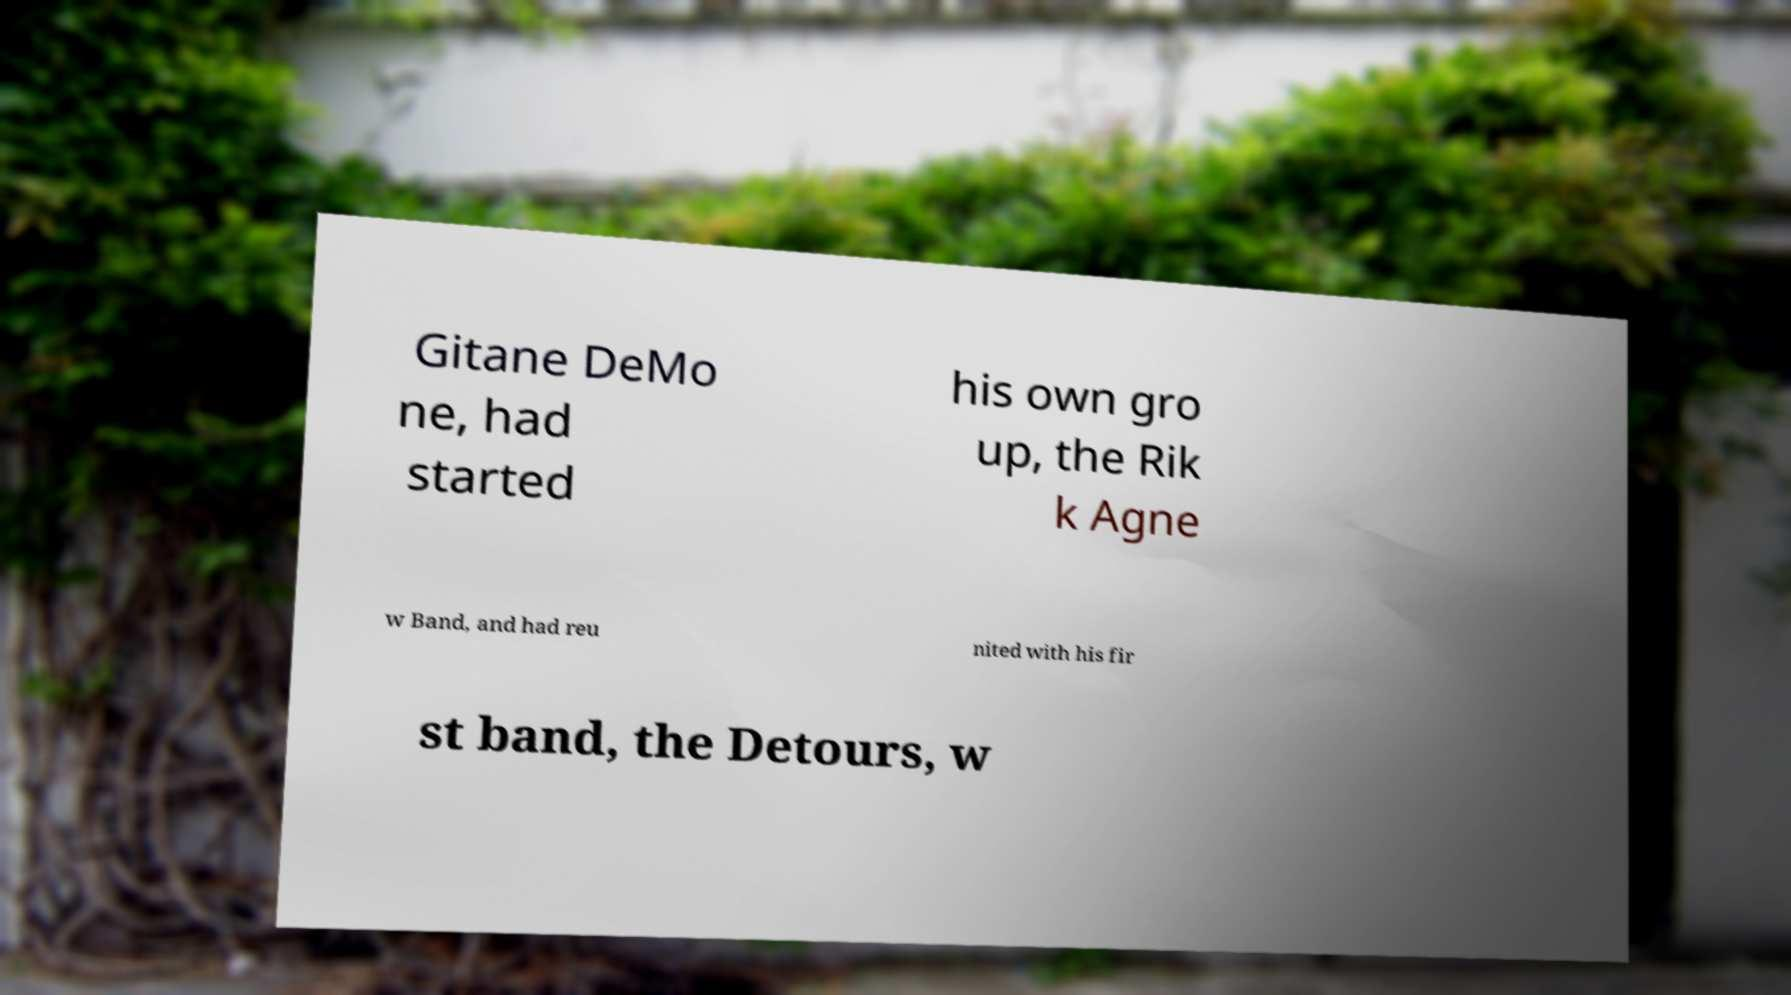I need the written content from this picture converted into text. Can you do that? Gitane DeMo ne, had started his own gro up, the Rik k Agne w Band, and had reu nited with his fir st band, the Detours, w 